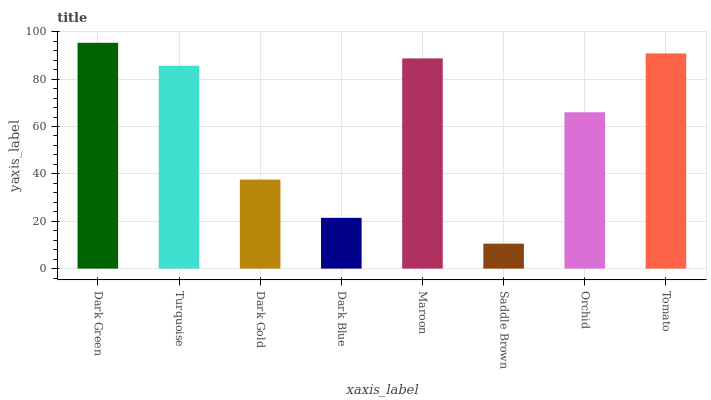Is Saddle Brown the minimum?
Answer yes or no. Yes. Is Dark Green the maximum?
Answer yes or no. Yes. Is Turquoise the minimum?
Answer yes or no. No. Is Turquoise the maximum?
Answer yes or no. No. Is Dark Green greater than Turquoise?
Answer yes or no. Yes. Is Turquoise less than Dark Green?
Answer yes or no. Yes. Is Turquoise greater than Dark Green?
Answer yes or no. No. Is Dark Green less than Turquoise?
Answer yes or no. No. Is Turquoise the high median?
Answer yes or no. Yes. Is Orchid the low median?
Answer yes or no. Yes. Is Saddle Brown the high median?
Answer yes or no. No. Is Dark Blue the low median?
Answer yes or no. No. 